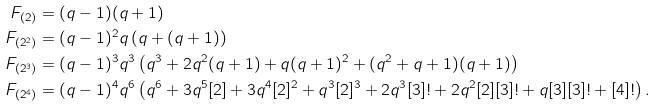<formula> <loc_0><loc_0><loc_500><loc_500>F _ { ( 2 ) } & = ( q - 1 ) ( q + 1 ) \\ F _ { ( 2 ^ { 2 } ) } & = ( q - 1 ) ^ { 2 } q \left ( q + ( q + 1 ) \right ) \\ F _ { ( 2 ^ { 3 } ) } & = ( q - 1 ) ^ { 3 } q ^ { 3 } \left ( q ^ { 3 } + 2 q ^ { 2 } ( q + 1 ) + q ( q + 1 ) ^ { 2 } + ( q ^ { 2 } + q + 1 ) ( q + 1 ) \right ) \\ F _ { ( 2 ^ { 4 } ) } & = ( q - 1 ) ^ { 4 } q ^ { 6 } \left ( q ^ { 6 } + 3 q ^ { 5 } [ 2 ] + 3 q ^ { 4 } [ 2 ] ^ { 2 } + q ^ { 3 } [ 2 ] ^ { 3 } + 2 q ^ { 3 } [ 3 ] ! + 2 q ^ { 2 } [ 2 ] [ 3 ] ! + q [ 3 ] [ 3 ] ! + [ 4 ] ! \right ) .</formula> 